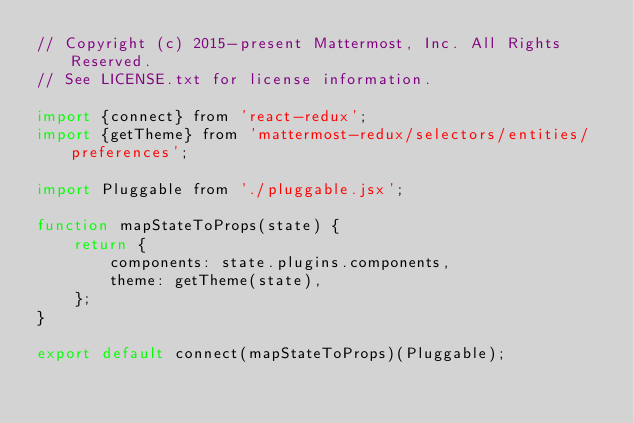Convert code to text. <code><loc_0><loc_0><loc_500><loc_500><_JavaScript_>// Copyright (c) 2015-present Mattermost, Inc. All Rights Reserved.
// See LICENSE.txt for license information.

import {connect} from 'react-redux';
import {getTheme} from 'mattermost-redux/selectors/entities/preferences';

import Pluggable from './pluggable.jsx';

function mapStateToProps(state) {
    return {
        components: state.plugins.components,
        theme: getTheme(state),
    };
}

export default connect(mapStateToProps)(Pluggable);
</code> 